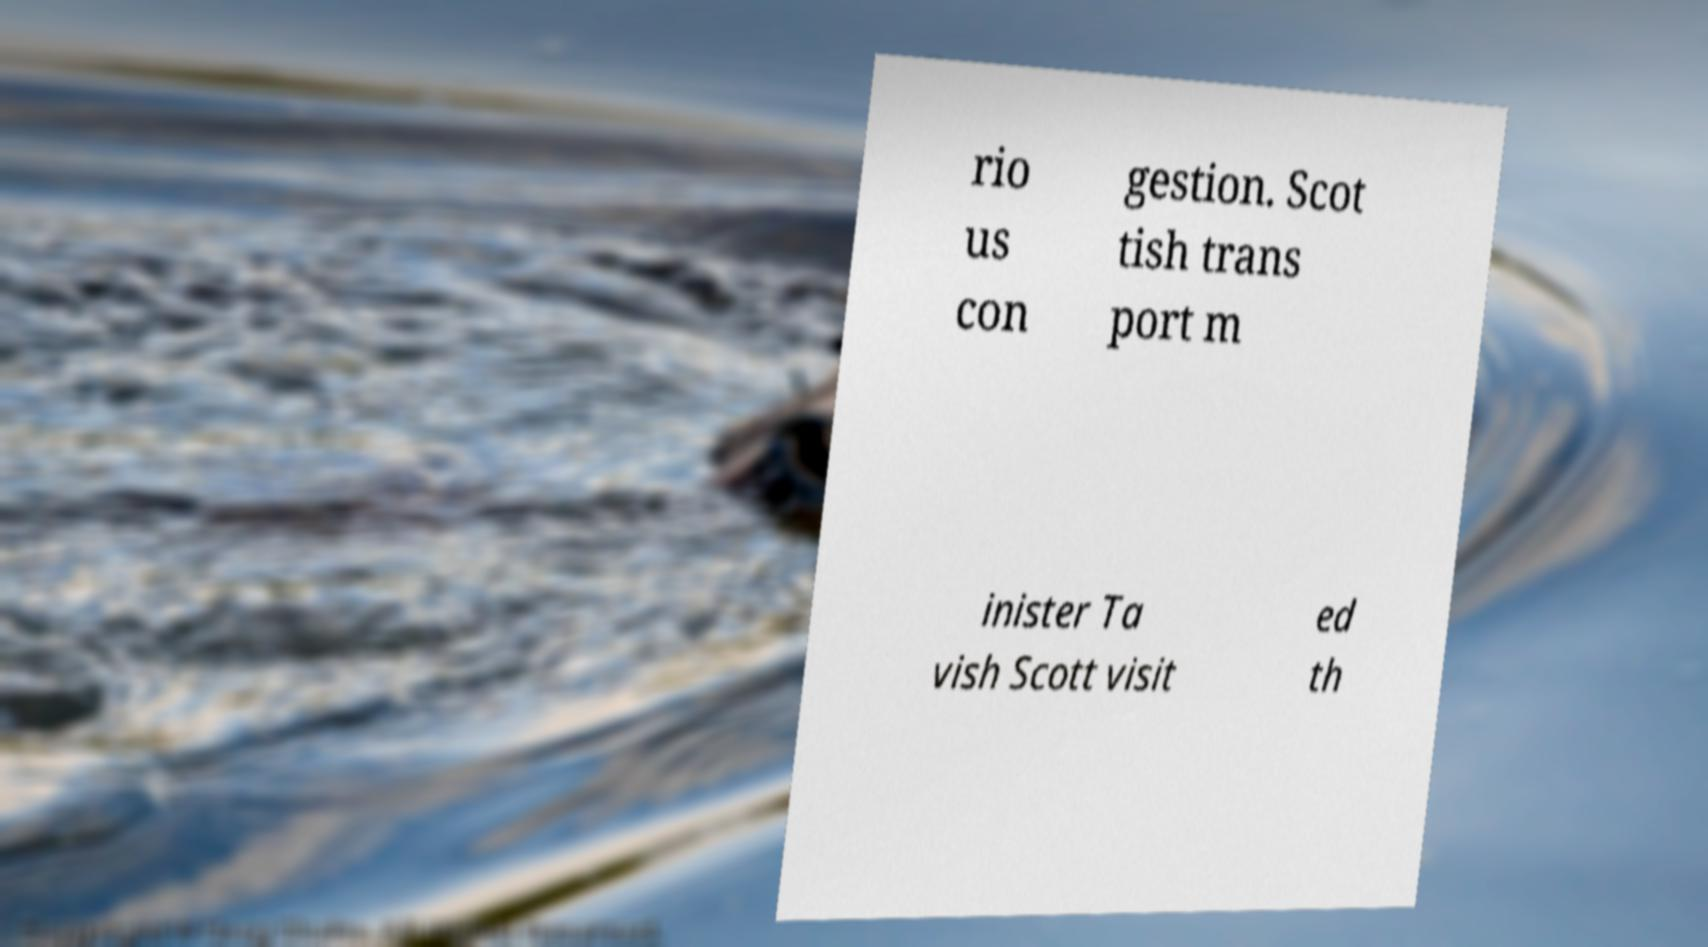There's text embedded in this image that I need extracted. Can you transcribe it verbatim? rio us con gestion. Scot tish trans port m inister Ta vish Scott visit ed th 